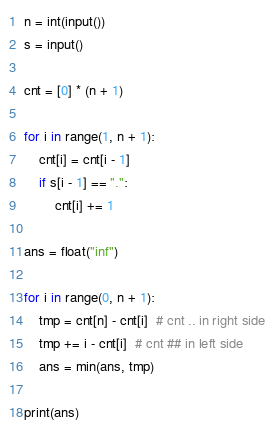Convert code to text. <code><loc_0><loc_0><loc_500><loc_500><_Python_>n = int(input())
s = input()

cnt = [0] * (n + 1)

for i in range(1, n + 1):
    cnt[i] = cnt[i - 1]
    if s[i - 1] == ".":
        cnt[i] += 1

ans = float("inf")

for i in range(0, n + 1):
    tmp = cnt[n] - cnt[i]  # cnt .. in right side
    tmp += i - cnt[i]  # cnt ## in left side
    ans = min(ans, tmp)

print(ans)
</code> 